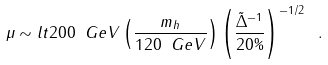Convert formula to latex. <formula><loc_0><loc_0><loc_500><loc_500>\mu \sim l t 2 0 0 \ G e V \left ( \frac { m _ { h } } { 1 2 0 \ G e V } \right ) \left ( \frac { \tilde { \Delta } ^ { - 1 } } { 2 0 \% } \right ) ^ { - 1 / 2 } \ .</formula> 